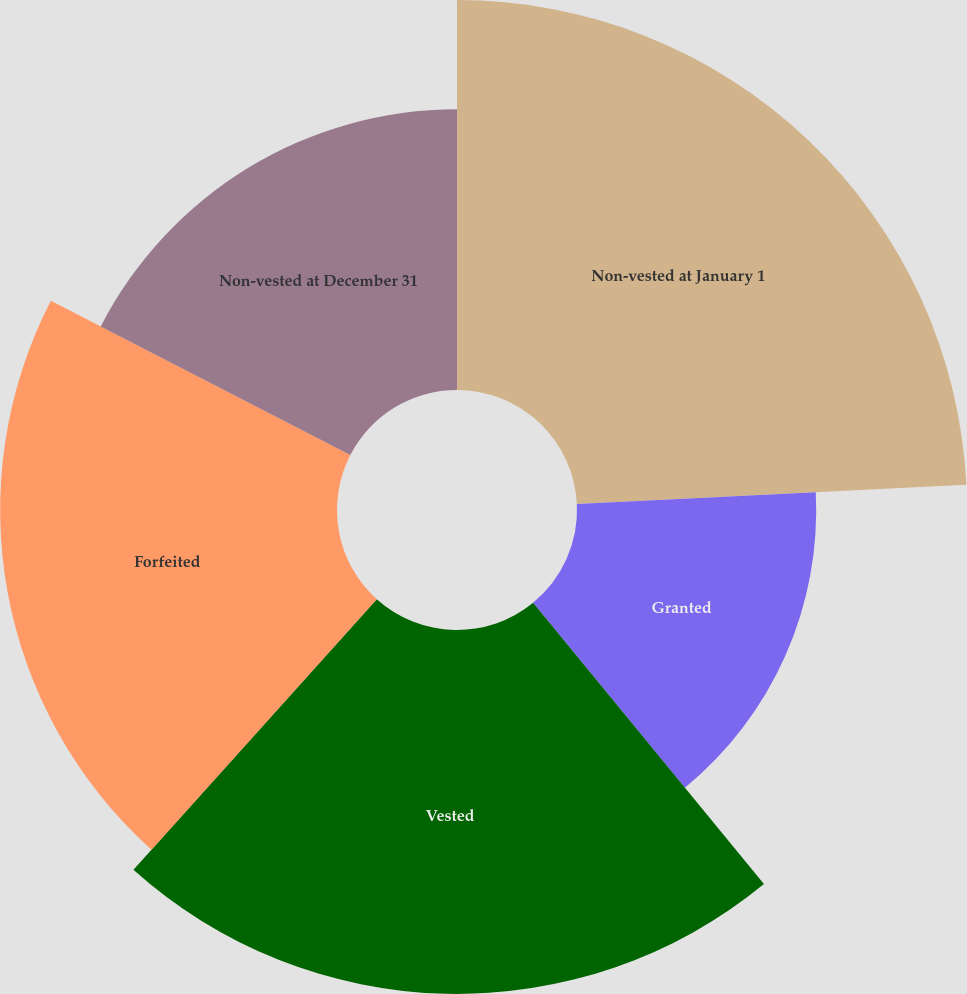<chart> <loc_0><loc_0><loc_500><loc_500><pie_chart><fcel>Non-vested at January 1<fcel>Granted<fcel>Vested<fcel>Forfeited<fcel>Non-vested at December 31<nl><fcel>24.21%<fcel>14.85%<fcel>22.59%<fcel>20.91%<fcel>17.43%<nl></chart> 